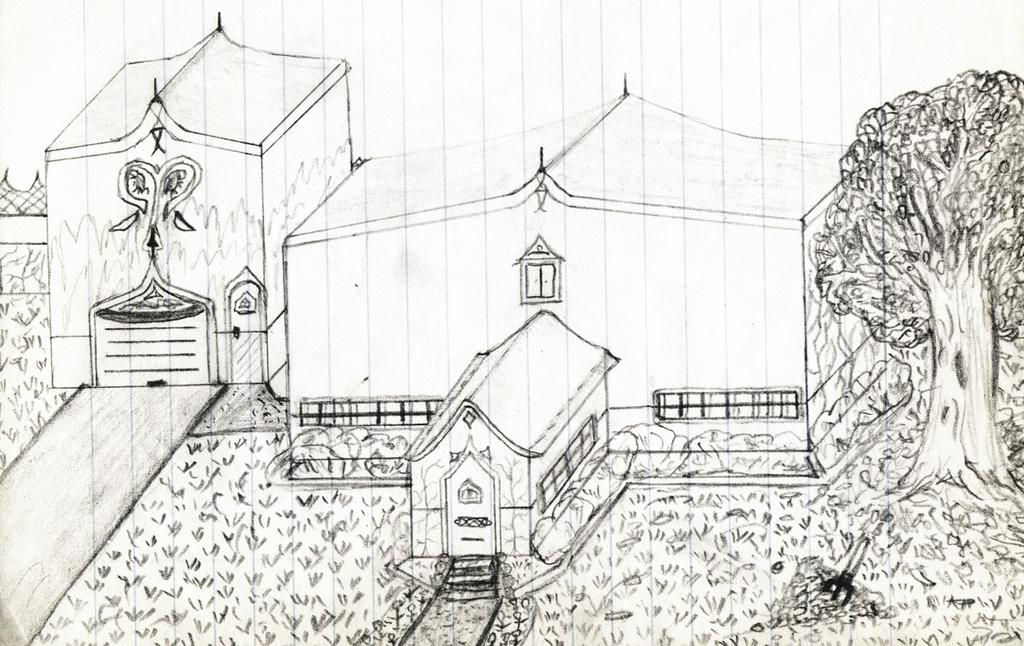What is depicted in the image? There is a drawing of a house in the image. What can be seen in the drawing besides the house? There are trees and grass on the ground in the drawing. Where is the faucet located in the drawing? There is no faucet present in the drawing; it only features a house, trees, and grass. 